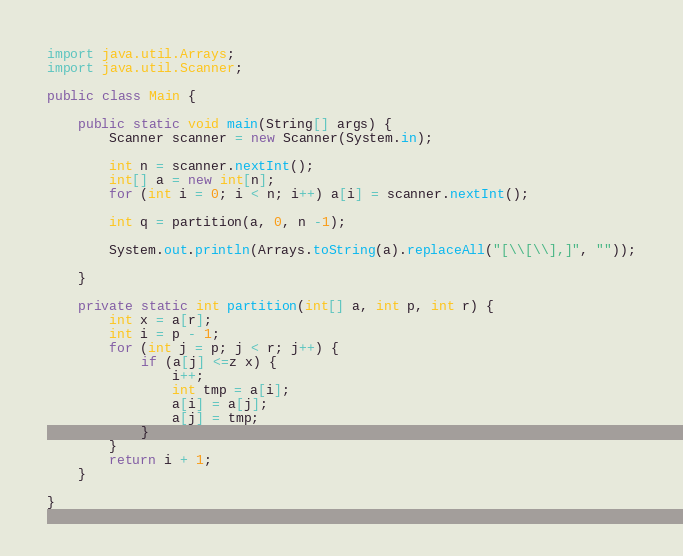<code> <loc_0><loc_0><loc_500><loc_500><_Java_>import java.util.Arrays;
import java.util.Scanner;

public class Main {

    public static void main(String[] args) {
        Scanner scanner = new Scanner(System.in);

        int n = scanner.nextInt();
        int[] a = new int[n];
        for (int i = 0; i < n; i++) a[i] = scanner.nextInt();

        int q = partition(a, 0, n -1);

        System.out.println(Arrays.toString(a).replaceAll("[\\[\\],]", ""));

    }

    private static int partition(int[] a, int p, int r) {
        int x = a[r];
        int i = p - 1;
        for (int j = p; j < r; j++) {
            if (a[j] <=z x) {
                i++;
                int tmp = a[i];
                a[i] = a[j];
                a[j] = tmp;
            }
        }
        return i + 1;
    }

}

</code> 